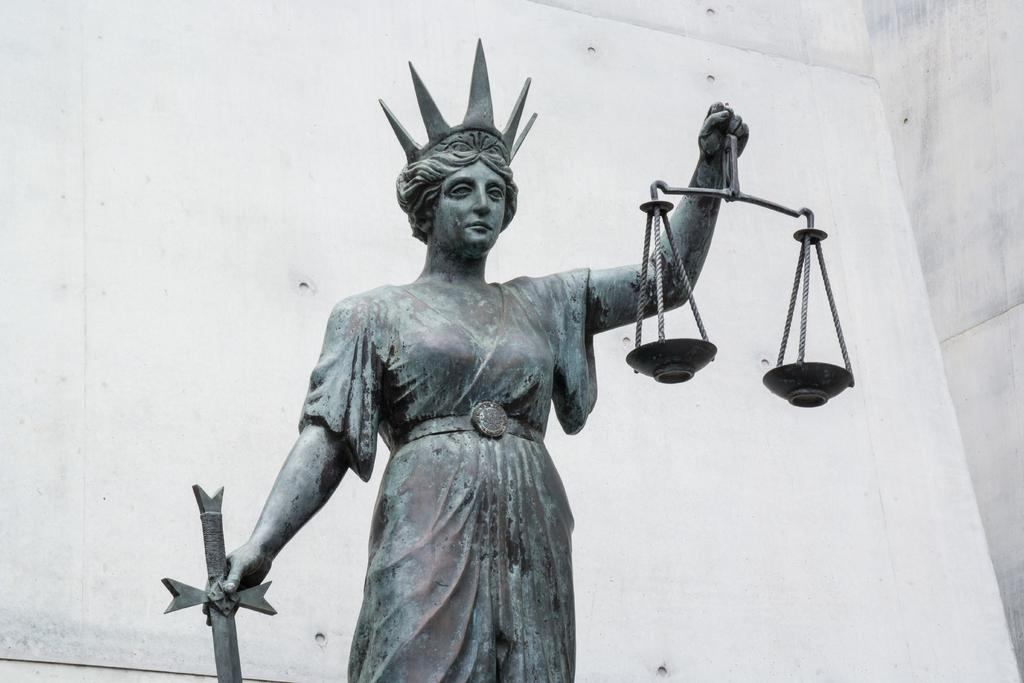What is the main subject of the image? There is a statue in the image. What is the statue doing or holding? The statue is holding some objects. What else can be seen in the image besides the statue? There is a wall in the image. What historical event is depicted by the statue in the image? There is no information provided about the historical context or event related to the statue in the image. 